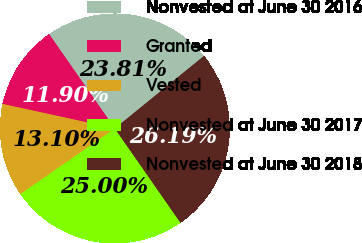Convert chart. <chart><loc_0><loc_0><loc_500><loc_500><pie_chart><fcel>Nonvested at June 30 2016<fcel>Granted<fcel>Vested<fcel>Nonvested at June 30 2017<fcel>Nonvested at June 30 2018<nl><fcel>23.81%<fcel>11.9%<fcel>13.1%<fcel>25.0%<fcel>26.19%<nl></chart> 